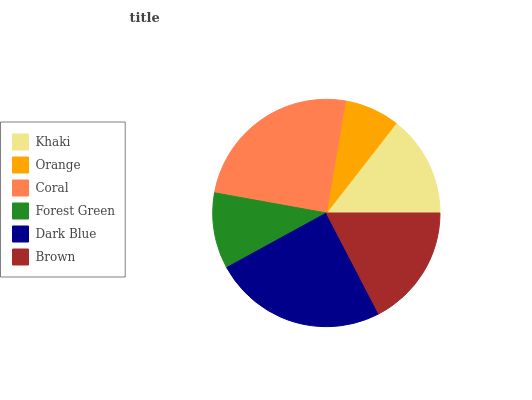Is Orange the minimum?
Answer yes or no. Yes. Is Coral the maximum?
Answer yes or no. Yes. Is Coral the minimum?
Answer yes or no. No. Is Orange the maximum?
Answer yes or no. No. Is Coral greater than Orange?
Answer yes or no. Yes. Is Orange less than Coral?
Answer yes or no. Yes. Is Orange greater than Coral?
Answer yes or no. No. Is Coral less than Orange?
Answer yes or no. No. Is Brown the high median?
Answer yes or no. Yes. Is Khaki the low median?
Answer yes or no. Yes. Is Dark Blue the high median?
Answer yes or no. No. Is Orange the low median?
Answer yes or no. No. 